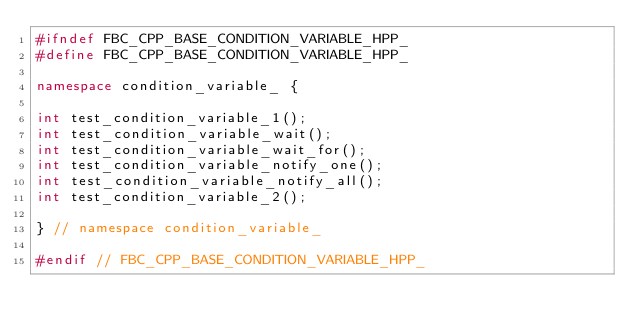Convert code to text. <code><loc_0><loc_0><loc_500><loc_500><_C++_>#ifndef FBC_CPP_BASE_CONDITION_VARIABLE_HPP_
#define FBC_CPP_BASE_CONDITION_VARIABLE_HPP_

namespace condition_variable_ {

int test_condition_variable_1();
int test_condition_variable_wait();
int test_condition_variable_wait_for();
int test_condition_variable_notify_one();
int test_condition_variable_notify_all();
int test_condition_variable_2();

} // namespace condition_variable_

#endif // FBC_CPP_BASE_CONDITION_VARIABLE_HPP_
</code> 